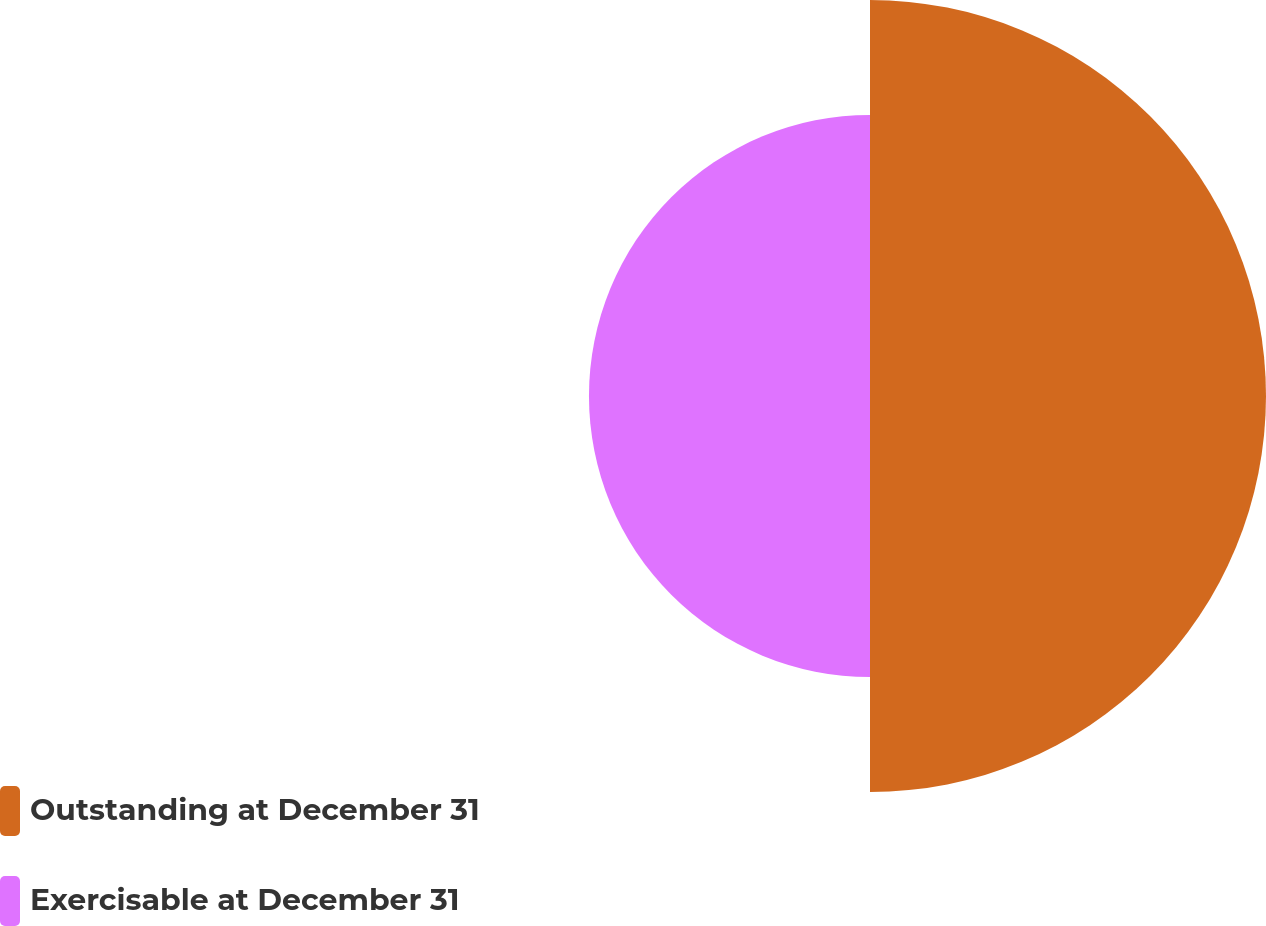<chart> <loc_0><loc_0><loc_500><loc_500><pie_chart><fcel>Outstanding at December 31<fcel>Exercisable at December 31<nl><fcel>58.49%<fcel>41.51%<nl></chart> 